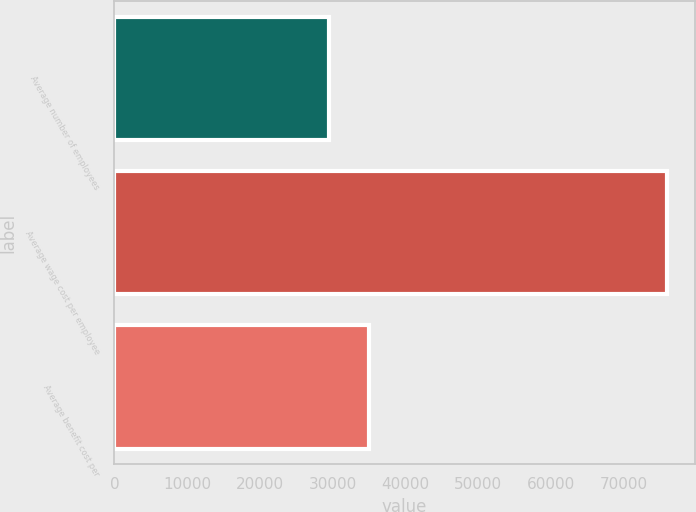Convert chart. <chart><loc_0><loc_0><loc_500><loc_500><bar_chart><fcel>Average number of employees<fcel>Average wage cost per employee<fcel>Average benefit cost per<nl><fcel>29482<fcel>76000<fcel>35000<nl></chart> 